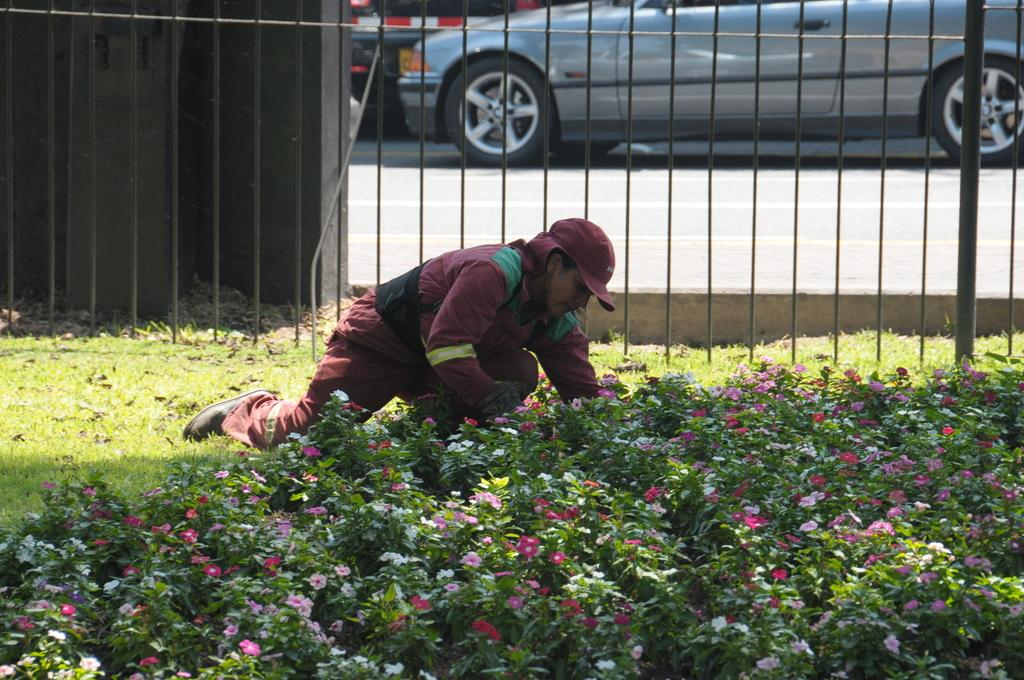Who or what is in the image? There is a person in the image. Where is the person located? The person is on the grass. What can be seen in front of the person? There are plants with flowers in front of the person. What is visible behind the person? There are iron grilles behind the person, and a car is on the road behind them. What type of shock can be seen affecting the person in the image? There is no shock present in the image; the person is simply standing on the grass. What kind of rail is visible near the person in the image? There is no rail present in the image; the person is standing near iron grilles. 